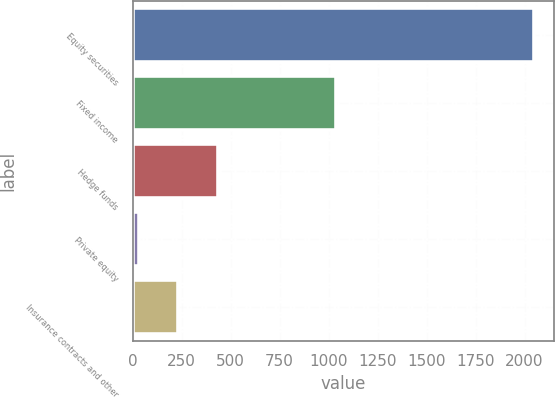Convert chart. <chart><loc_0><loc_0><loc_500><loc_500><bar_chart><fcel>Equity securities<fcel>Fixed income<fcel>Hedge funds<fcel>Private equity<fcel>Insurance contracts and other<nl><fcel>2050<fcel>1040<fcel>434<fcel>30<fcel>232<nl></chart> 